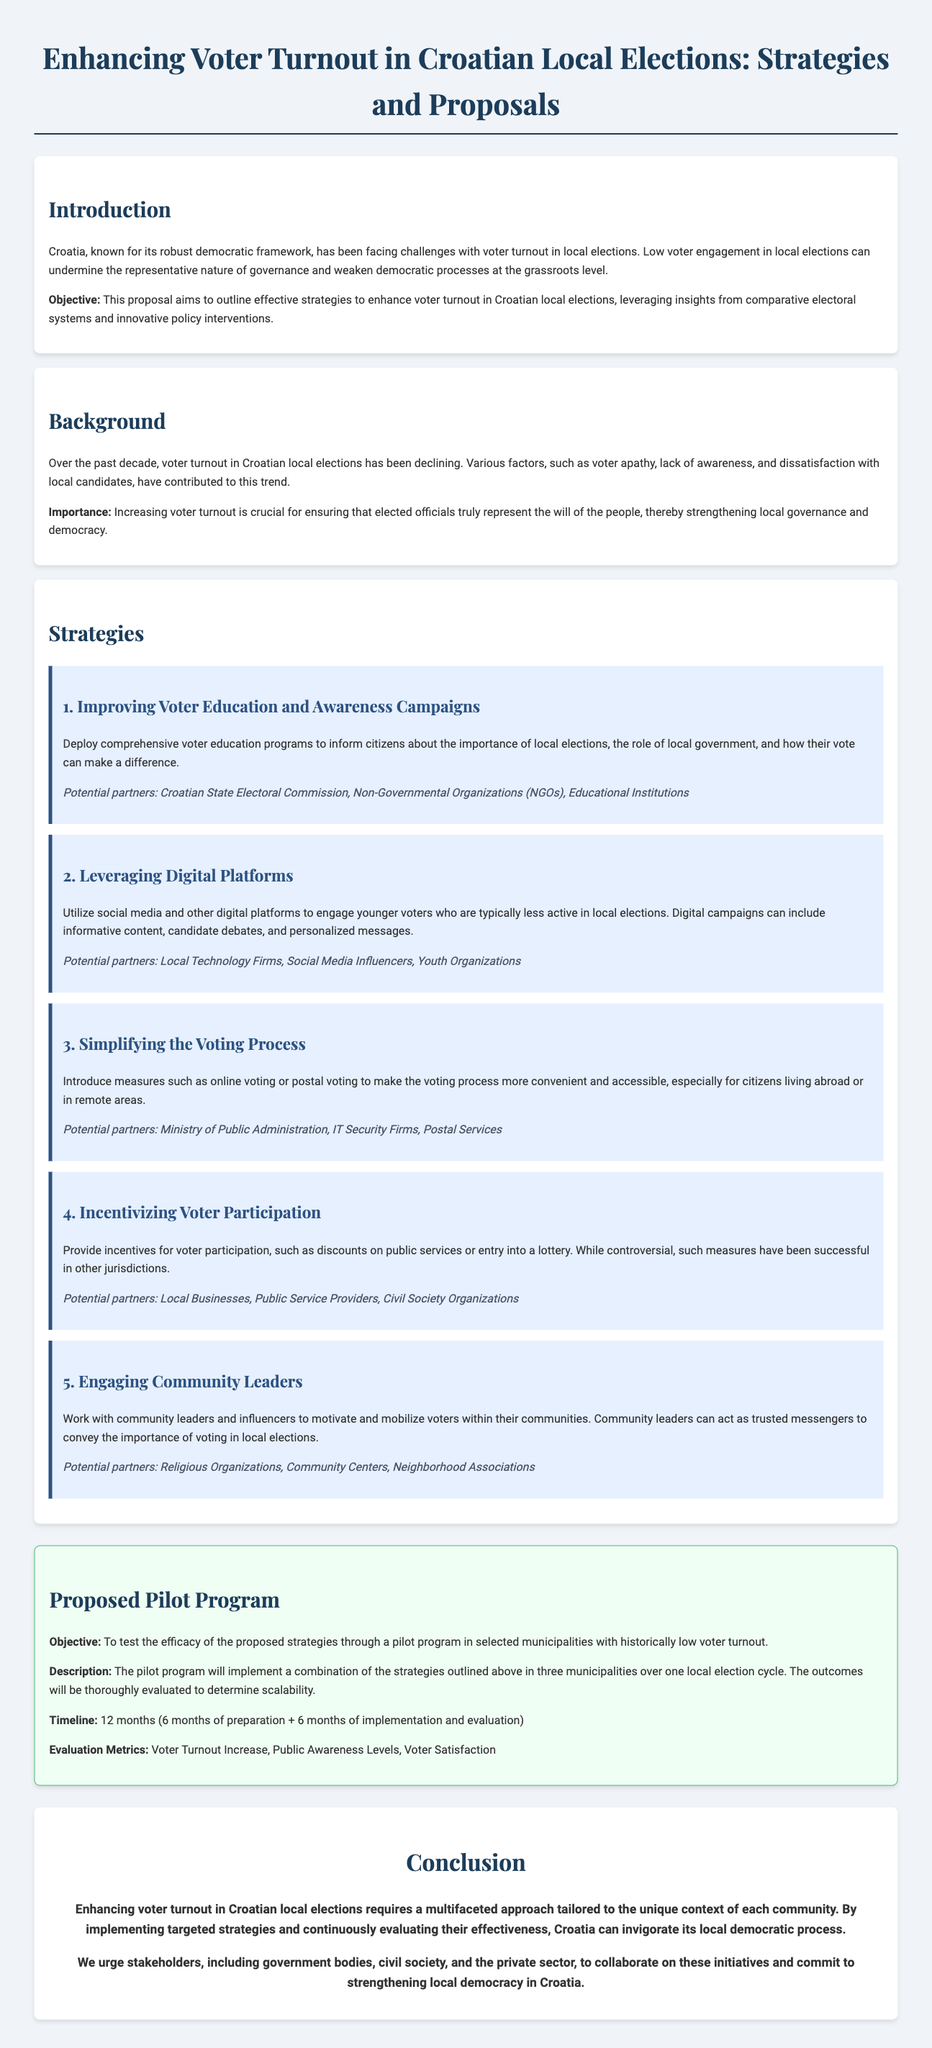What is the main objective of the proposal? The main objective of the proposal is to outline effective strategies to enhance voter turnout in Croatian local elections.
Answer: Enhance voter turnout What is one of the reasons for declining voter turnout in Croatia? The document mentions various factors contributing to declining voter turnout, including voter apathy.
Answer: Voter apathy Which strategy focuses on using social media to engage younger voters? The strategy that mentions utilizing social media and digital platforms aims to engage younger voters.
Answer: Leveraging Digital Platforms How long is the proposed pilot program planned to run? The timeline for the proposed pilot program indicates it will run for 12 months.
Answer: 12 months Which organization is listed as a potential partner for improving voter education? The Croatian State Electoral Commission is listed as a potential partner for improving voter education and awareness campaigns.
Answer: Croatian State Electoral Commission What is the proposed method to simplify the voting process? The proposal includes introducing online voting or postal voting to make the voting process more convenient.
Answer: Online voting or postal voting What is the evaluation metric related to the voter experience? Voter satisfaction is mentioned as one of the evaluation metrics for the pilot program.
Answer: Voter Satisfaction Which community groups are suggested to engage community leaders? Religious organizations and community centers are suggested as groups to engage community leaders for mobilizing voters.
Answer: Religious Organizations, Community Centers What is the importance of increasing voter turnout as stated in the document? The document states that increasing voter turnout is crucial for ensuring elected officials truly represent the will of the people.
Answer: Represent the will of the people 